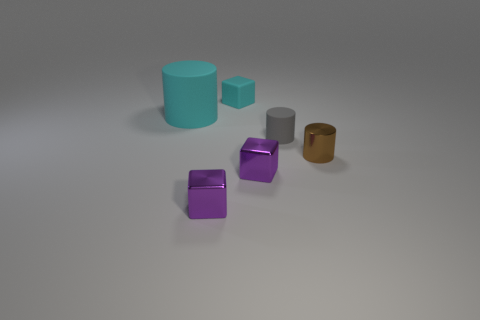Add 1 tiny brown matte spheres. How many objects exist? 7 Subtract 0 purple balls. How many objects are left? 6 Subtract all shiny blocks. Subtract all small purple metal blocks. How many objects are left? 2 Add 6 large cyan cylinders. How many large cyan cylinders are left? 7 Add 1 big green rubber spheres. How many big green rubber spheres exist? 1 